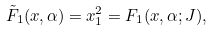Convert formula to latex. <formula><loc_0><loc_0><loc_500><loc_500>{ \tilde { F } } _ { 1 } ( x , \alpha ) = x _ { 1 } ^ { 2 } = F _ { 1 } ( x , \alpha ; J ) ,</formula> 